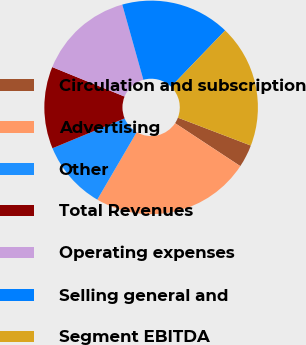Convert chart. <chart><loc_0><loc_0><loc_500><loc_500><pie_chart><fcel>Circulation and subscription<fcel>Advertising<fcel>Other<fcel>Total Revenues<fcel>Operating expenses<fcel>Selling general and<fcel>Segment EBITDA<nl><fcel>3.45%<fcel>24.14%<fcel>10.34%<fcel>12.41%<fcel>14.48%<fcel>16.55%<fcel>18.62%<nl></chart> 